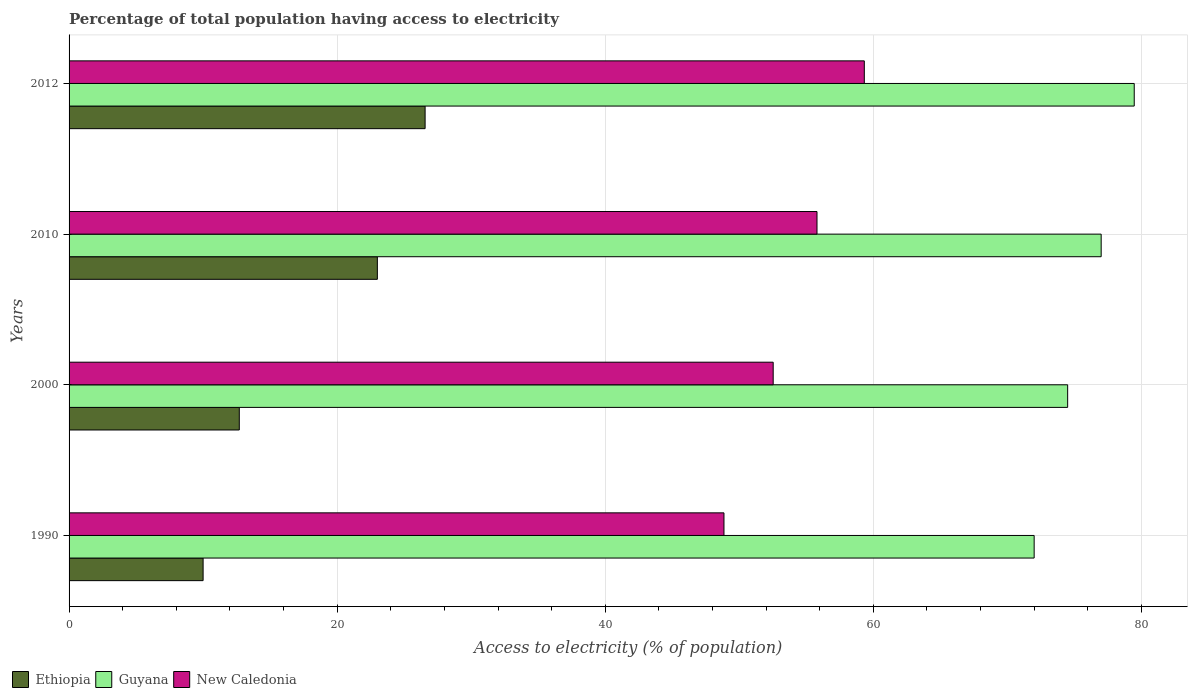How many different coloured bars are there?
Give a very brief answer. 3. Are the number of bars on each tick of the Y-axis equal?
Provide a succinct answer. Yes. What is the label of the 2nd group of bars from the top?
Make the answer very short. 2010. In how many cases, is the number of bars for a given year not equal to the number of legend labels?
Offer a terse response. 0. What is the percentage of population that have access to electricity in New Caledonia in 1990?
Your response must be concise. 48.86. Across all years, what is the maximum percentage of population that have access to electricity in Ethiopia?
Make the answer very short. 26.56. Across all years, what is the minimum percentage of population that have access to electricity in New Caledonia?
Provide a short and direct response. 48.86. In which year was the percentage of population that have access to electricity in Guyana maximum?
Your answer should be compact. 2012. What is the total percentage of population that have access to electricity in Ethiopia in the graph?
Your answer should be compact. 72.26. What is the difference between the percentage of population that have access to electricity in Ethiopia in 2010 and the percentage of population that have access to electricity in Guyana in 2000?
Ensure brevity in your answer.  -51.5. What is the average percentage of population that have access to electricity in New Caledonia per year?
Your answer should be compact. 54.13. In the year 2012, what is the difference between the percentage of population that have access to electricity in Guyana and percentage of population that have access to electricity in New Caledonia?
Provide a short and direct response. 20.14. What is the ratio of the percentage of population that have access to electricity in Ethiopia in 1990 to that in 2010?
Give a very brief answer. 0.43. Is the percentage of population that have access to electricity in New Caledonia in 2010 less than that in 2012?
Your answer should be very brief. Yes. Is the difference between the percentage of population that have access to electricity in Guyana in 2000 and 2012 greater than the difference between the percentage of population that have access to electricity in New Caledonia in 2000 and 2012?
Your answer should be compact. Yes. What is the difference between the highest and the second highest percentage of population that have access to electricity in Guyana?
Provide a succinct answer. 2.47. What is the difference between the highest and the lowest percentage of population that have access to electricity in Guyana?
Provide a succinct answer. 7.47. What does the 1st bar from the top in 2012 represents?
Make the answer very short. New Caledonia. What does the 1st bar from the bottom in 1990 represents?
Offer a terse response. Ethiopia. Is it the case that in every year, the sum of the percentage of population that have access to electricity in Ethiopia and percentage of population that have access to electricity in New Caledonia is greater than the percentage of population that have access to electricity in Guyana?
Provide a succinct answer. No. Are all the bars in the graph horizontal?
Offer a very short reply. Yes. Are the values on the major ticks of X-axis written in scientific E-notation?
Ensure brevity in your answer.  No. Does the graph contain any zero values?
Offer a very short reply. No. How many legend labels are there?
Your answer should be very brief. 3. How are the legend labels stacked?
Your answer should be very brief. Horizontal. What is the title of the graph?
Make the answer very short. Percentage of total population having access to electricity. Does "Hungary" appear as one of the legend labels in the graph?
Make the answer very short. No. What is the label or title of the X-axis?
Provide a short and direct response. Access to electricity (% of population). What is the Access to electricity (% of population) of Ethiopia in 1990?
Ensure brevity in your answer.  10. What is the Access to electricity (% of population) in Guyana in 1990?
Make the answer very short. 72. What is the Access to electricity (% of population) in New Caledonia in 1990?
Make the answer very short. 48.86. What is the Access to electricity (% of population) in Guyana in 2000?
Give a very brief answer. 74.5. What is the Access to electricity (% of population) of New Caledonia in 2000?
Give a very brief answer. 52.53. What is the Access to electricity (% of population) in Ethiopia in 2010?
Provide a short and direct response. 23. What is the Access to electricity (% of population) in New Caledonia in 2010?
Ensure brevity in your answer.  55.8. What is the Access to electricity (% of population) of Ethiopia in 2012?
Your response must be concise. 26.56. What is the Access to electricity (% of population) of Guyana in 2012?
Your answer should be very brief. 79.47. What is the Access to electricity (% of population) in New Caledonia in 2012?
Ensure brevity in your answer.  59.33. Across all years, what is the maximum Access to electricity (% of population) in Ethiopia?
Offer a terse response. 26.56. Across all years, what is the maximum Access to electricity (% of population) of Guyana?
Offer a very short reply. 79.47. Across all years, what is the maximum Access to electricity (% of population) in New Caledonia?
Provide a short and direct response. 59.33. Across all years, what is the minimum Access to electricity (% of population) of New Caledonia?
Your response must be concise. 48.86. What is the total Access to electricity (% of population) in Ethiopia in the graph?
Your response must be concise. 72.26. What is the total Access to electricity (% of population) in Guyana in the graph?
Offer a terse response. 302.97. What is the total Access to electricity (% of population) in New Caledonia in the graph?
Provide a succinct answer. 216.52. What is the difference between the Access to electricity (% of population) of New Caledonia in 1990 and that in 2000?
Provide a short and direct response. -3.67. What is the difference between the Access to electricity (% of population) of New Caledonia in 1990 and that in 2010?
Offer a terse response. -6.94. What is the difference between the Access to electricity (% of population) of Ethiopia in 1990 and that in 2012?
Offer a very short reply. -16.56. What is the difference between the Access to electricity (% of population) in Guyana in 1990 and that in 2012?
Keep it short and to the point. -7.47. What is the difference between the Access to electricity (% of population) in New Caledonia in 1990 and that in 2012?
Offer a very short reply. -10.47. What is the difference between the Access to electricity (% of population) in Ethiopia in 2000 and that in 2010?
Provide a succinct answer. -10.3. What is the difference between the Access to electricity (% of population) of Guyana in 2000 and that in 2010?
Make the answer very short. -2.5. What is the difference between the Access to electricity (% of population) in New Caledonia in 2000 and that in 2010?
Offer a terse response. -3.27. What is the difference between the Access to electricity (% of population) in Ethiopia in 2000 and that in 2012?
Your answer should be very brief. -13.86. What is the difference between the Access to electricity (% of population) in Guyana in 2000 and that in 2012?
Offer a very short reply. -4.97. What is the difference between the Access to electricity (% of population) in New Caledonia in 2000 and that in 2012?
Keep it short and to the point. -6.8. What is the difference between the Access to electricity (% of population) of Ethiopia in 2010 and that in 2012?
Provide a succinct answer. -3.56. What is the difference between the Access to electricity (% of population) of Guyana in 2010 and that in 2012?
Make the answer very short. -2.47. What is the difference between the Access to electricity (% of population) of New Caledonia in 2010 and that in 2012?
Offer a very short reply. -3.53. What is the difference between the Access to electricity (% of population) in Ethiopia in 1990 and the Access to electricity (% of population) in Guyana in 2000?
Your answer should be compact. -64.5. What is the difference between the Access to electricity (% of population) in Ethiopia in 1990 and the Access to electricity (% of population) in New Caledonia in 2000?
Keep it short and to the point. -42.53. What is the difference between the Access to electricity (% of population) in Guyana in 1990 and the Access to electricity (% of population) in New Caledonia in 2000?
Provide a short and direct response. 19.47. What is the difference between the Access to electricity (% of population) of Ethiopia in 1990 and the Access to electricity (% of population) of Guyana in 2010?
Your answer should be compact. -67. What is the difference between the Access to electricity (% of population) in Ethiopia in 1990 and the Access to electricity (% of population) in New Caledonia in 2010?
Your answer should be very brief. -45.8. What is the difference between the Access to electricity (% of population) in Guyana in 1990 and the Access to electricity (% of population) in New Caledonia in 2010?
Provide a short and direct response. 16.2. What is the difference between the Access to electricity (% of population) of Ethiopia in 1990 and the Access to electricity (% of population) of Guyana in 2012?
Your answer should be very brief. -69.47. What is the difference between the Access to electricity (% of population) in Ethiopia in 1990 and the Access to electricity (% of population) in New Caledonia in 2012?
Offer a terse response. -49.33. What is the difference between the Access to electricity (% of population) of Guyana in 1990 and the Access to electricity (% of population) of New Caledonia in 2012?
Give a very brief answer. 12.67. What is the difference between the Access to electricity (% of population) in Ethiopia in 2000 and the Access to electricity (% of population) in Guyana in 2010?
Your response must be concise. -64.3. What is the difference between the Access to electricity (% of population) in Ethiopia in 2000 and the Access to electricity (% of population) in New Caledonia in 2010?
Your answer should be very brief. -43.1. What is the difference between the Access to electricity (% of population) of Guyana in 2000 and the Access to electricity (% of population) of New Caledonia in 2010?
Give a very brief answer. 18.7. What is the difference between the Access to electricity (% of population) in Ethiopia in 2000 and the Access to electricity (% of population) in Guyana in 2012?
Provide a short and direct response. -66.77. What is the difference between the Access to electricity (% of population) in Ethiopia in 2000 and the Access to electricity (% of population) in New Caledonia in 2012?
Ensure brevity in your answer.  -46.63. What is the difference between the Access to electricity (% of population) of Guyana in 2000 and the Access to electricity (% of population) of New Caledonia in 2012?
Make the answer very short. 15.17. What is the difference between the Access to electricity (% of population) of Ethiopia in 2010 and the Access to electricity (% of population) of Guyana in 2012?
Make the answer very short. -56.47. What is the difference between the Access to electricity (% of population) of Ethiopia in 2010 and the Access to electricity (% of population) of New Caledonia in 2012?
Ensure brevity in your answer.  -36.33. What is the difference between the Access to electricity (% of population) in Guyana in 2010 and the Access to electricity (% of population) in New Caledonia in 2012?
Ensure brevity in your answer.  17.67. What is the average Access to electricity (% of population) in Ethiopia per year?
Your answer should be compact. 18.07. What is the average Access to electricity (% of population) in Guyana per year?
Your answer should be very brief. 75.74. What is the average Access to electricity (% of population) of New Caledonia per year?
Offer a very short reply. 54.13. In the year 1990, what is the difference between the Access to electricity (% of population) of Ethiopia and Access to electricity (% of population) of Guyana?
Offer a very short reply. -62. In the year 1990, what is the difference between the Access to electricity (% of population) in Ethiopia and Access to electricity (% of population) in New Caledonia?
Your answer should be very brief. -38.86. In the year 1990, what is the difference between the Access to electricity (% of population) of Guyana and Access to electricity (% of population) of New Caledonia?
Offer a terse response. 23.14. In the year 2000, what is the difference between the Access to electricity (% of population) of Ethiopia and Access to electricity (% of population) of Guyana?
Give a very brief answer. -61.8. In the year 2000, what is the difference between the Access to electricity (% of population) in Ethiopia and Access to electricity (% of population) in New Caledonia?
Give a very brief answer. -39.83. In the year 2000, what is the difference between the Access to electricity (% of population) in Guyana and Access to electricity (% of population) in New Caledonia?
Your answer should be compact. 21.97. In the year 2010, what is the difference between the Access to electricity (% of population) of Ethiopia and Access to electricity (% of population) of Guyana?
Your answer should be very brief. -54. In the year 2010, what is the difference between the Access to electricity (% of population) of Ethiopia and Access to electricity (% of population) of New Caledonia?
Your response must be concise. -32.8. In the year 2010, what is the difference between the Access to electricity (% of population) in Guyana and Access to electricity (% of population) in New Caledonia?
Offer a very short reply. 21.2. In the year 2012, what is the difference between the Access to electricity (% of population) of Ethiopia and Access to electricity (% of population) of Guyana?
Your response must be concise. -52.9. In the year 2012, what is the difference between the Access to electricity (% of population) of Ethiopia and Access to electricity (% of population) of New Caledonia?
Offer a terse response. -32.77. In the year 2012, what is the difference between the Access to electricity (% of population) in Guyana and Access to electricity (% of population) in New Caledonia?
Offer a terse response. 20.14. What is the ratio of the Access to electricity (% of population) of Ethiopia in 1990 to that in 2000?
Your answer should be compact. 0.79. What is the ratio of the Access to electricity (% of population) in Guyana in 1990 to that in 2000?
Give a very brief answer. 0.97. What is the ratio of the Access to electricity (% of population) of New Caledonia in 1990 to that in 2000?
Your answer should be very brief. 0.93. What is the ratio of the Access to electricity (% of population) in Ethiopia in 1990 to that in 2010?
Ensure brevity in your answer.  0.43. What is the ratio of the Access to electricity (% of population) of Guyana in 1990 to that in 2010?
Offer a very short reply. 0.94. What is the ratio of the Access to electricity (% of population) in New Caledonia in 1990 to that in 2010?
Offer a very short reply. 0.88. What is the ratio of the Access to electricity (% of population) in Ethiopia in 1990 to that in 2012?
Make the answer very short. 0.38. What is the ratio of the Access to electricity (% of population) of Guyana in 1990 to that in 2012?
Keep it short and to the point. 0.91. What is the ratio of the Access to electricity (% of population) of New Caledonia in 1990 to that in 2012?
Provide a short and direct response. 0.82. What is the ratio of the Access to electricity (% of population) in Ethiopia in 2000 to that in 2010?
Offer a very short reply. 0.55. What is the ratio of the Access to electricity (% of population) in Guyana in 2000 to that in 2010?
Ensure brevity in your answer.  0.97. What is the ratio of the Access to electricity (% of population) of New Caledonia in 2000 to that in 2010?
Your answer should be compact. 0.94. What is the ratio of the Access to electricity (% of population) of Ethiopia in 2000 to that in 2012?
Your answer should be very brief. 0.48. What is the ratio of the Access to electricity (% of population) in Guyana in 2000 to that in 2012?
Make the answer very short. 0.94. What is the ratio of the Access to electricity (% of population) of New Caledonia in 2000 to that in 2012?
Make the answer very short. 0.89. What is the ratio of the Access to electricity (% of population) in Ethiopia in 2010 to that in 2012?
Make the answer very short. 0.87. What is the ratio of the Access to electricity (% of population) of Guyana in 2010 to that in 2012?
Your answer should be very brief. 0.97. What is the ratio of the Access to electricity (% of population) of New Caledonia in 2010 to that in 2012?
Your answer should be very brief. 0.94. What is the difference between the highest and the second highest Access to electricity (% of population) of Ethiopia?
Make the answer very short. 3.56. What is the difference between the highest and the second highest Access to electricity (% of population) in Guyana?
Offer a very short reply. 2.47. What is the difference between the highest and the second highest Access to electricity (% of population) of New Caledonia?
Your response must be concise. 3.53. What is the difference between the highest and the lowest Access to electricity (% of population) in Ethiopia?
Offer a very short reply. 16.56. What is the difference between the highest and the lowest Access to electricity (% of population) in Guyana?
Give a very brief answer. 7.47. What is the difference between the highest and the lowest Access to electricity (% of population) in New Caledonia?
Give a very brief answer. 10.47. 